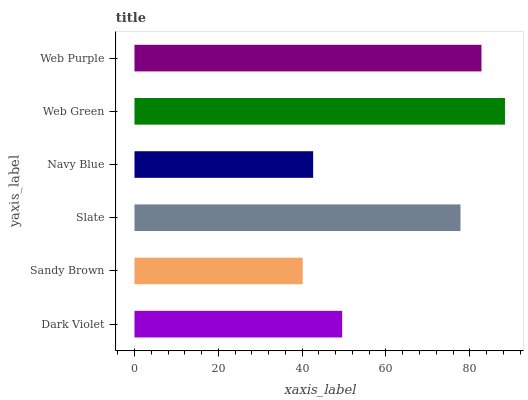Is Sandy Brown the minimum?
Answer yes or no. Yes. Is Web Green the maximum?
Answer yes or no. Yes. Is Slate the minimum?
Answer yes or no. No. Is Slate the maximum?
Answer yes or no. No. Is Slate greater than Sandy Brown?
Answer yes or no. Yes. Is Sandy Brown less than Slate?
Answer yes or no. Yes. Is Sandy Brown greater than Slate?
Answer yes or no. No. Is Slate less than Sandy Brown?
Answer yes or no. No. Is Slate the high median?
Answer yes or no. Yes. Is Dark Violet the low median?
Answer yes or no. Yes. Is Dark Violet the high median?
Answer yes or no. No. Is Slate the low median?
Answer yes or no. No. 